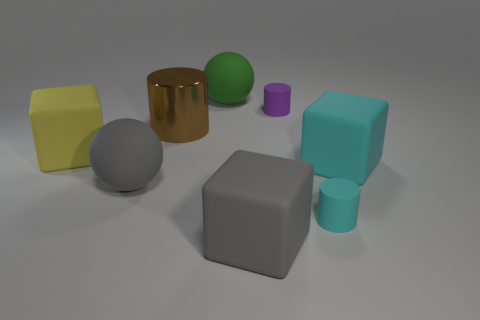What is the color of the shiny thing?
Keep it short and to the point. Brown. What material is the large cube in front of the small cyan object?
Provide a succinct answer. Rubber. There is a small cyan matte object; is it the same shape as the gray matte thing on the left side of the large metallic cylinder?
Give a very brief answer. No. Is the number of small yellow rubber blocks greater than the number of purple things?
Make the answer very short. No. Are there any other things that have the same color as the large cylinder?
Provide a succinct answer. No. What shape is the tiny purple object that is made of the same material as the large green thing?
Ensure brevity in your answer.  Cylinder. What material is the large sphere in front of the cyan matte thing right of the tiny cyan thing?
Ensure brevity in your answer.  Rubber. There is a gray matte object left of the big brown metal thing; is it the same shape as the big green thing?
Offer a terse response. Yes. Are there more large cubes that are in front of the brown cylinder than brown metal cylinders?
Your answer should be compact. Yes. Are there any other things that have the same material as the brown object?
Give a very brief answer. No. 